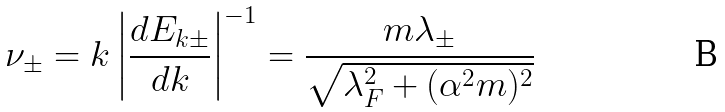Convert formula to latex. <formula><loc_0><loc_0><loc_500><loc_500>\nu _ { \pm } = k \left | \frac { d E _ { k \pm } } { d k } \right | ^ { - 1 } = \frac { m \lambda _ { \pm } } { \sqrt { \lambda _ { F } ^ { 2 } + ( \alpha ^ { 2 } m ) ^ { 2 } } }</formula> 